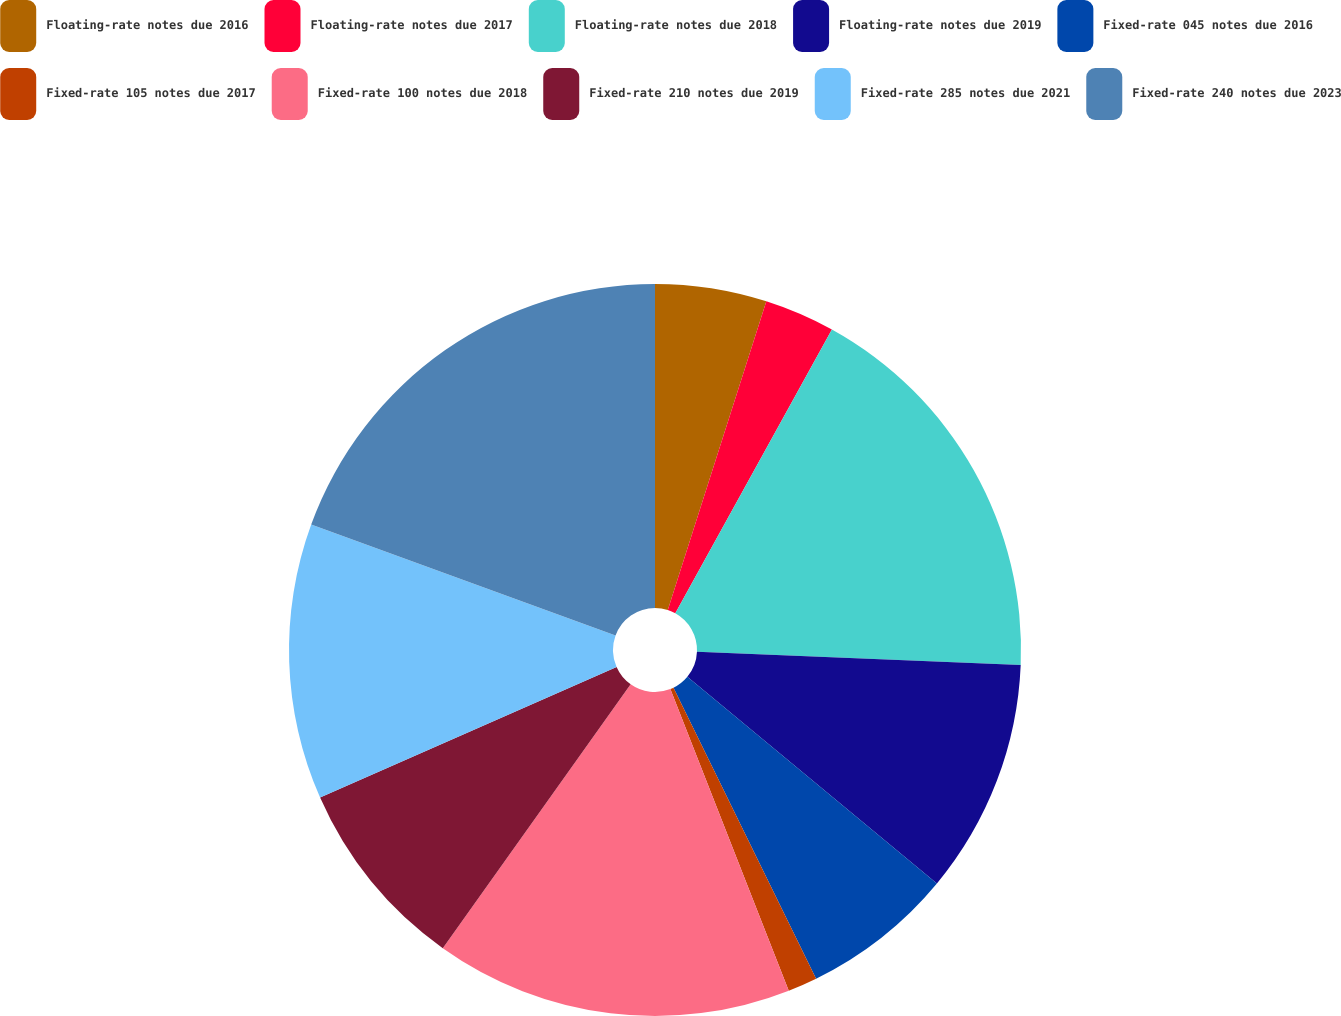Convert chart. <chart><loc_0><loc_0><loc_500><loc_500><pie_chart><fcel>Floating-rate notes due 2016<fcel>Floating-rate notes due 2017<fcel>Floating-rate notes due 2018<fcel>Floating-rate notes due 2019<fcel>Fixed-rate 045 notes due 2016<fcel>Fixed-rate 105 notes due 2017<fcel>Fixed-rate 100 notes due 2018<fcel>Fixed-rate 210 notes due 2019<fcel>Fixed-rate 285 notes due 2021<fcel>Fixed-rate 240 notes due 2023<nl><fcel>4.92%<fcel>3.11%<fcel>17.62%<fcel>10.36%<fcel>6.74%<fcel>1.3%<fcel>15.8%<fcel>8.55%<fcel>12.18%<fcel>19.43%<nl></chart> 